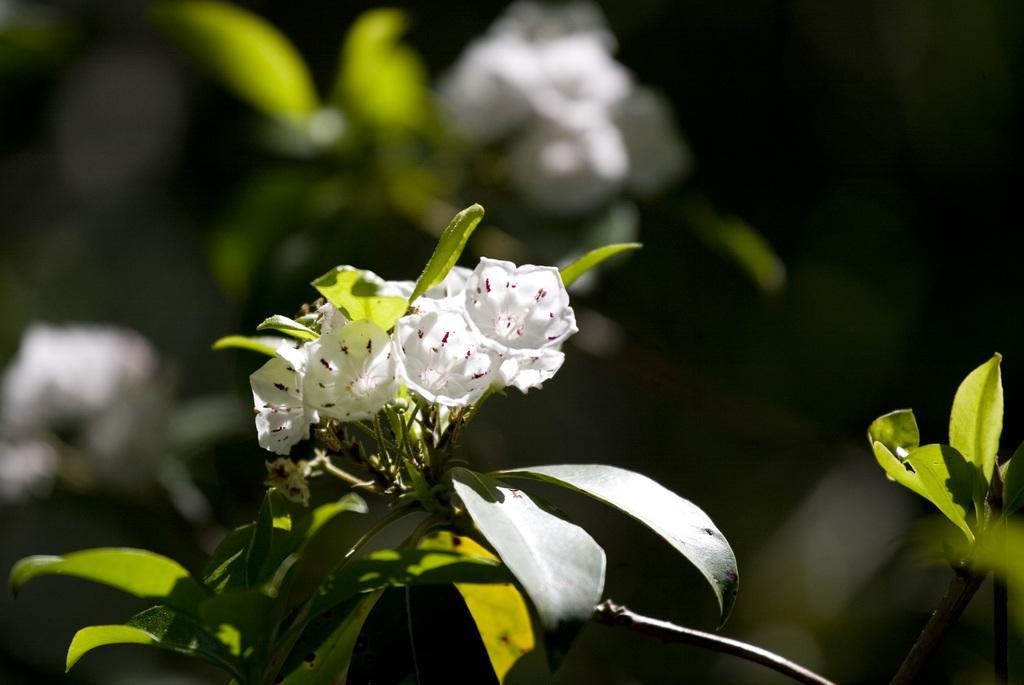Describe this image in one or two sentences. This is a zoomed in picture. In the foreground we can see the white color flowers, green color leaves of the plant. The background of the image is blurry and in the background we can see the plants and flowers. 